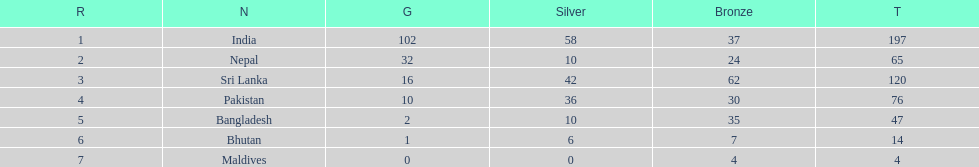How many countries have one more than 10 gold medals? 3. 